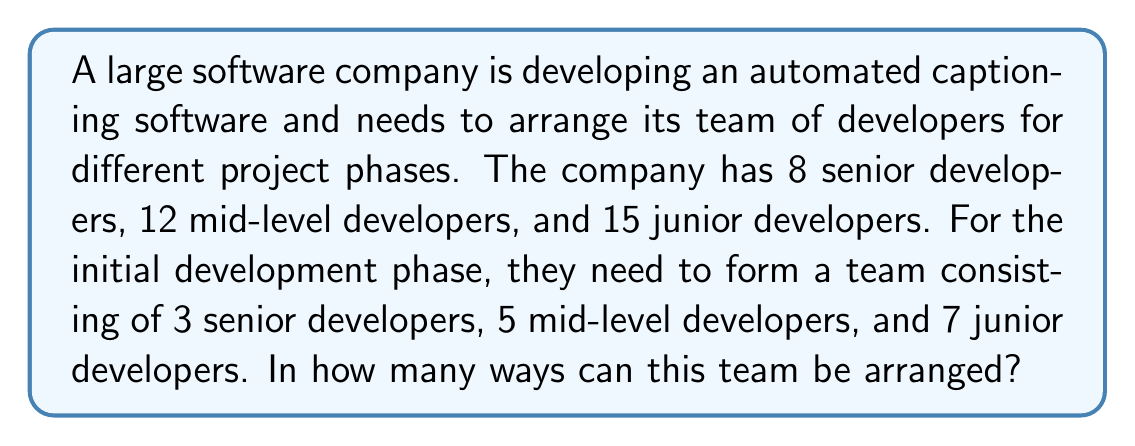Can you solve this math problem? To solve this problem, we need to use the multiplication principle of counting and the concept of permutations. Let's break it down step-by-step:

1. Selecting senior developers:
   We need to choose 3 out of 8 senior developers. This can be done in $\binom{8}{3}$ ways.
   $$\binom{8}{3} = \frac{8!}{3!(8-3)!} = \frac{8!}{3!5!} = 56$$

2. Selecting mid-level developers:
   We need to choose 5 out of 12 mid-level developers. This can be done in $\binom{12}{5}$ ways.
   $$\binom{12}{5} = \frac{12!}{5!(12-5)!} = \frac{12!}{5!7!} = 792$$

3. Selecting junior developers:
   We need to choose 7 out of 15 junior developers. This can be done in $\binom{15}{7}$ ways.
   $$\binom{15}{7} = \frac{15!}{7!(15-7)!} = \frac{15!}{7!8!} = 6,435$$

4. Arranging the selected developers:
   Once we have selected the developers, we need to arrange them. The total number of developers in the team is 3 + 5 + 7 = 15. This can be done in 15! ways.

5. Applying the multiplication principle:
   The total number of ways to arrange the team is the product of the number of ways to select each type of developer and the number of ways to arrange them:

   $$56 \times 792 \times 6,435 \times 15!$$

This gives us the final result.
Answer: The number of ways to arrange the team is:

$$56 \times 792 \times 6,435 \times 15! = 3,075,519,464,601,600,000,000$$

or approximately $3.08 \times 10^{21}$ 